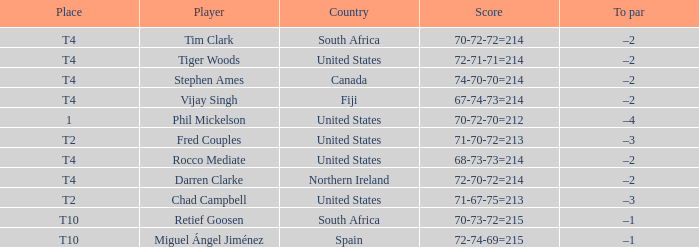Write the full table. {'header': ['Place', 'Player', 'Country', 'Score', 'To par'], 'rows': [['T4', 'Tim Clark', 'South Africa', '70-72-72=214', '–2'], ['T4', 'Tiger Woods', 'United States', '72-71-71=214', '–2'], ['T4', 'Stephen Ames', 'Canada', '74-70-70=214', '–2'], ['T4', 'Vijay Singh', 'Fiji', '67-74-73=214', '–2'], ['1', 'Phil Mickelson', 'United States', '70-72-70=212', '–4'], ['T2', 'Fred Couples', 'United States', '71-70-72=213', '–3'], ['T4', 'Rocco Mediate', 'United States', '68-73-73=214', '–2'], ['T4', 'Darren Clarke', 'Northern Ireland', '72-70-72=214', '–2'], ['T2', 'Chad Campbell', 'United States', '71-67-75=213', '–3'], ['T10', 'Retief Goosen', 'South Africa', '70-73-72=215', '–1'], ['T10', 'Miguel Ángel Jiménez', 'Spain', '72-74-69=215', '–1']]} What country does Rocco Mediate play for? United States. 